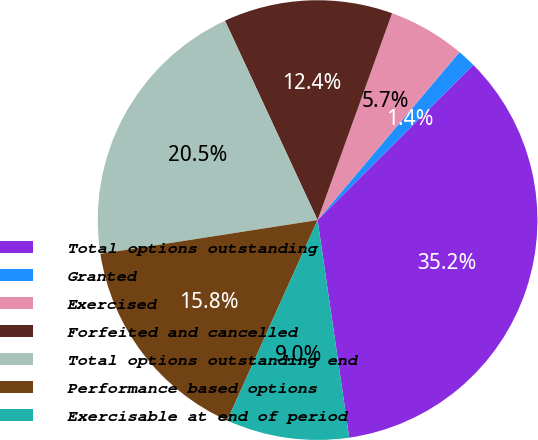<chart> <loc_0><loc_0><loc_500><loc_500><pie_chart><fcel>Total options outstanding<fcel>Granted<fcel>Exercised<fcel>Forfeited and cancelled<fcel>Total options outstanding end<fcel>Performance based options<fcel>Exercisable at end of period<nl><fcel>35.18%<fcel>1.36%<fcel>5.66%<fcel>12.42%<fcel>20.54%<fcel>15.8%<fcel>9.04%<nl></chart> 